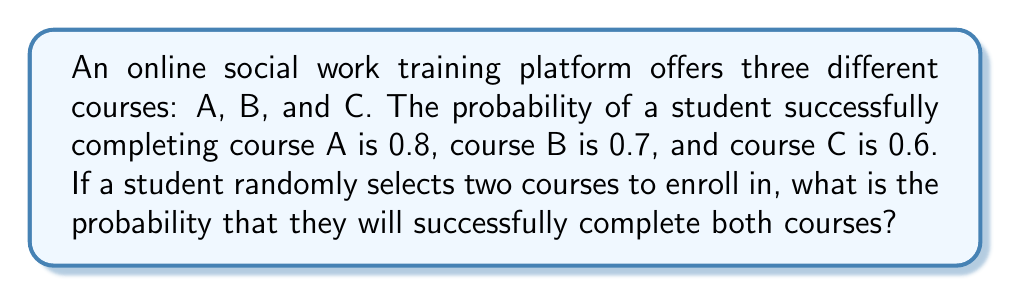Teach me how to tackle this problem. To solve this problem, we need to follow these steps:

1. List all possible combinations of two courses:
   (A,B), (A,C), and (B,C)

2. Calculate the probability of success for each combination:

   For (A,B):
   $P(A \text{ and } B) = P(A) \times P(B) = 0.8 \times 0.7 = 0.56$

   For (A,C):
   $P(A \text{ and } C) = P(A) \times P(C) = 0.8 \times 0.6 = 0.48$

   For (B,C):
   $P(B \text{ and } C) = P(B) \times P(C) = 0.7 \times 0.6 = 0.42$

3. Calculate the probability of selecting each combination:
   Since the student randomly selects two courses out of three, each combination has an equal probability of $\frac{1}{3}$.

4. Apply the law of total probability:
   $$P(\text{success}) = P(A \text{ and } B) \times \frac{1}{3} + P(A \text{ and } C) \times \frac{1}{3} + P(B \text{ and } C) \times \frac{1}{3}$$

5. Substitute the values:
   $$P(\text{success}) = 0.56 \times \frac{1}{3} + 0.48 \times \frac{1}{3} + 0.42 \times \frac{1}{3}$$

6. Simplify:
   $$P(\text{success}) = \frac{0.56 + 0.48 + 0.42}{3} = \frac{1.46}{3} \approx 0.4867$$
Answer: $\frac{1.46}{3}$ or approximately 0.4867 